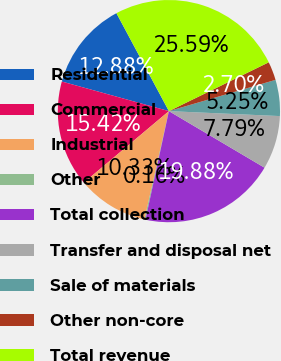Convert chart to OTSL. <chart><loc_0><loc_0><loc_500><loc_500><pie_chart><fcel>Residential<fcel>Commercial<fcel>Industrial<fcel>Other<fcel>Total collection<fcel>Transfer and disposal net<fcel>Sale of materials<fcel>Other non-core<fcel>Total revenue<nl><fcel>12.88%<fcel>15.42%<fcel>10.33%<fcel>0.16%<fcel>19.88%<fcel>7.79%<fcel>5.25%<fcel>2.7%<fcel>25.59%<nl></chart> 